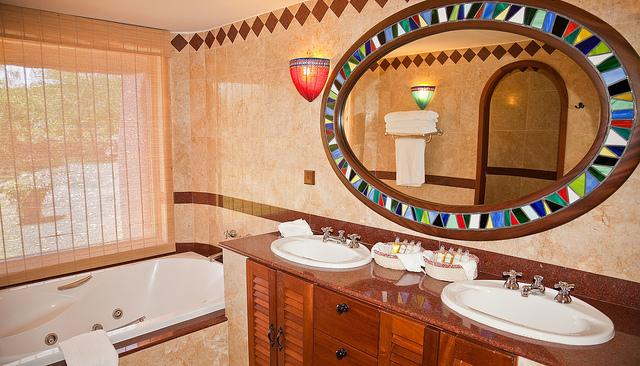What materials likely make up the colorful frame of the mirror? Please explain your reasoning. porcelain. A mirror has a colorful glass frame. 